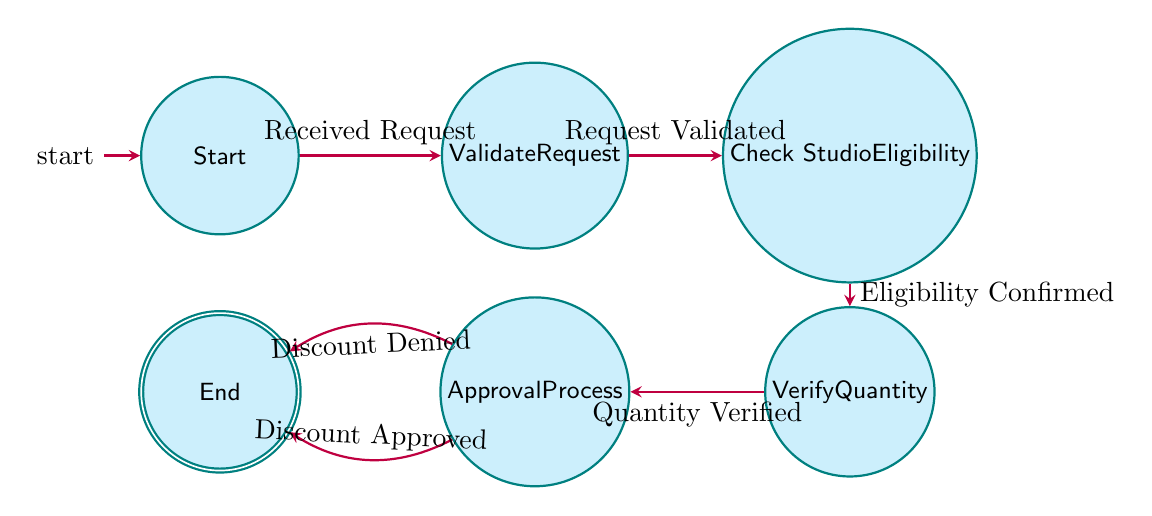What is the initial state of the diagram? The initial state is labeled as "Start". In state machine diagrams, the starting point is indicated by the initial marker, which shows the first point of action in the process.
Answer: Start How many states are there in total? Counting the states shown in the diagram, there are six distinct states: Start, Validate Request, Check Studio Eligibility, Verify Quantity, Approval Process, and End.
Answer: Six What transition occurs from 'Validate Request' to 'Check Studio Eligibility'? The transition from 'Validate Request' to 'Check Studio Eligibility' is labeled "Request Validated". This indicates that once the request has been validated, the process moves to checking studio eligibility.
Answer: Request Validated Which state follows 'Check Studio Eligibility'? The state that follows 'Check Studio Eligibility' is 'Verify Quantity'. In the flow of the diagram, it is clear that after checking eligibility, the next step is to verify the quantity of requested materials.
Answer: Verify Quantity What happens if the discount is denied in the 'Approval Process'? If the discount is denied, the process transitions to the 'End' state with the label "Discount Denied". This indicates the termination of the discount verification process with a negative outcome.
Answer: End What is the final state of the discount verification process? The final state of the process is labeled 'End'. This state signifies that the verification process has concluded regardless of whether the outcome was approval or denial.
Answer: End What labels are associated with the transitions from 'Approval Process'? There are two labels associated with transitions from 'Approval Process': "Discount Approved" and "Discount Denied". These labels represent the different outcomes of the approval process.
Answer: Discount Approved, Discount Denied Which state precedes the 'Approval Process'? The state that precedes 'Approval Process' is 'Verify Quantity'. This shows that verifying the quantity of art materials must be completed before proceeding to the approval of the discount.
Answer: Verify Quantity What is the transition name between 'Start' and 'Validate Request'? The transition name between 'Start' and 'Validate Request' is "Received Request". This indicates the action that initiates the discount verification process.
Answer: Received Request 